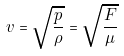Convert formula to latex. <formula><loc_0><loc_0><loc_500><loc_500>v = \sqrt { \frac { p } { \rho } } = \sqrt { \frac { F } { \mu } }</formula> 